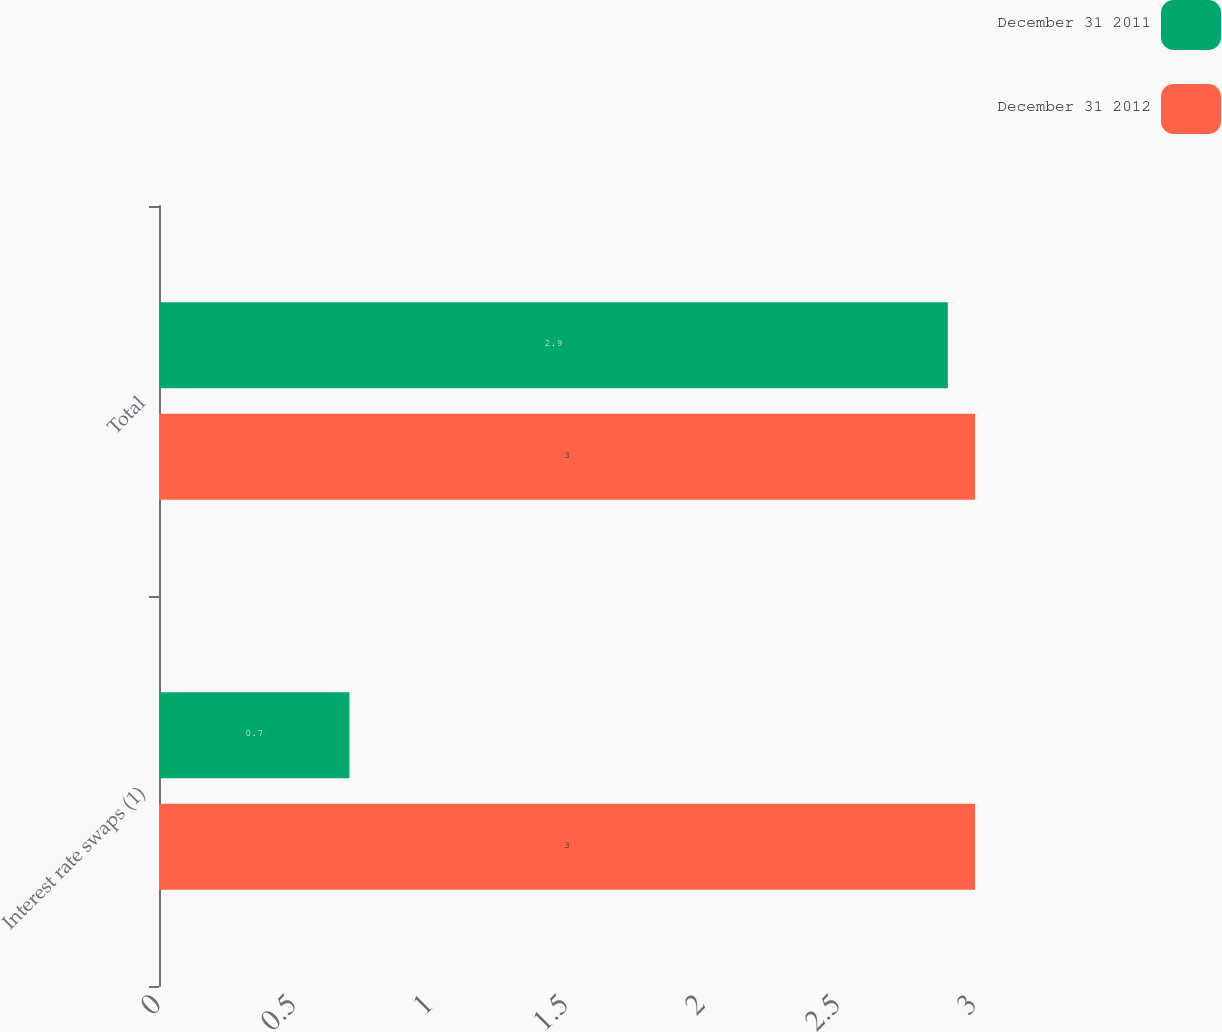Convert chart to OTSL. <chart><loc_0><loc_0><loc_500><loc_500><stacked_bar_chart><ecel><fcel>Interest rate swaps (1)<fcel>Total<nl><fcel>December 31 2011<fcel>0.7<fcel>2.9<nl><fcel>December 31 2012<fcel>3<fcel>3<nl></chart> 